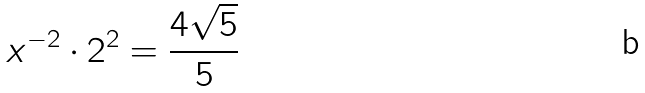Convert formula to latex. <formula><loc_0><loc_0><loc_500><loc_500>x ^ { - 2 } \cdot 2 ^ { 2 } = \frac { 4 \sqrt { 5 } } { 5 }</formula> 